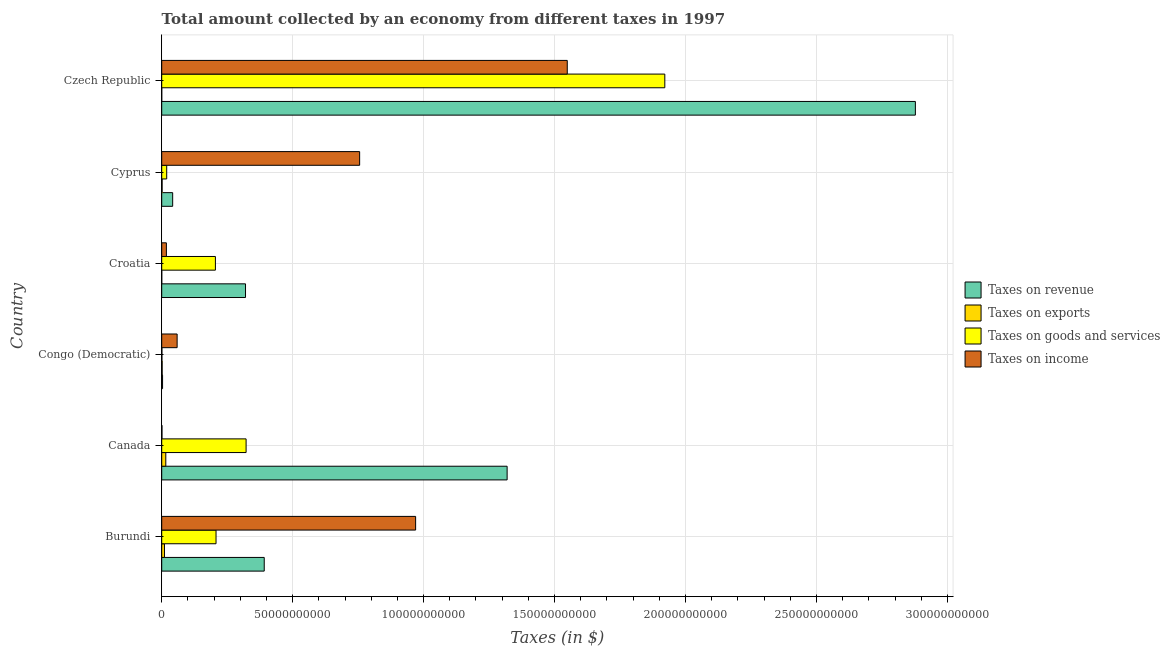How many groups of bars are there?
Offer a terse response. 6. What is the label of the 4th group of bars from the top?
Make the answer very short. Congo (Democratic). In how many cases, is the number of bars for a given country not equal to the number of legend labels?
Provide a short and direct response. 0. What is the amount collected as tax on goods in Cyprus?
Offer a terse response. 1.91e+09. Across all countries, what is the maximum amount collected as tax on income?
Make the answer very short. 1.55e+11. Across all countries, what is the minimum amount collected as tax on exports?
Ensure brevity in your answer.  4.00e+06. In which country was the amount collected as tax on exports maximum?
Ensure brevity in your answer.  Canada. In which country was the amount collected as tax on income minimum?
Offer a terse response. Canada. What is the total amount collected as tax on goods in the graph?
Ensure brevity in your answer.  2.68e+11. What is the difference between the amount collected as tax on goods in Canada and that in Cyprus?
Offer a very short reply. 3.03e+1. What is the difference between the amount collected as tax on goods in Croatia and the amount collected as tax on revenue in Canada?
Give a very brief answer. -1.11e+11. What is the average amount collected as tax on revenue per country?
Make the answer very short. 8.26e+1. What is the difference between the amount collected as tax on revenue and amount collected as tax on exports in Czech Republic?
Your response must be concise. 2.88e+11. What is the ratio of the amount collected as tax on income in Burundi to that in Congo (Democratic)?
Make the answer very short. 16.47. Is the amount collected as tax on goods in Canada less than that in Congo (Democratic)?
Offer a terse response. No. Is the difference between the amount collected as tax on income in Congo (Democratic) and Croatia greater than the difference between the amount collected as tax on revenue in Congo (Democratic) and Croatia?
Provide a succinct answer. Yes. What is the difference between the highest and the second highest amount collected as tax on income?
Give a very brief answer. 5.79e+1. What is the difference between the highest and the lowest amount collected as tax on revenue?
Provide a short and direct response. 2.87e+11. Is it the case that in every country, the sum of the amount collected as tax on revenue and amount collected as tax on goods is greater than the sum of amount collected as tax on exports and amount collected as tax on income?
Ensure brevity in your answer.  No. What does the 1st bar from the top in Canada represents?
Provide a succinct answer. Taxes on income. What does the 2nd bar from the bottom in Congo (Democratic) represents?
Your answer should be very brief. Taxes on exports. Is it the case that in every country, the sum of the amount collected as tax on revenue and amount collected as tax on exports is greater than the amount collected as tax on goods?
Provide a succinct answer. Yes. How many bars are there?
Provide a short and direct response. 24. Are all the bars in the graph horizontal?
Make the answer very short. Yes. How many countries are there in the graph?
Your response must be concise. 6. What is the difference between two consecutive major ticks on the X-axis?
Ensure brevity in your answer.  5.00e+1. Where does the legend appear in the graph?
Offer a very short reply. Center right. How many legend labels are there?
Keep it short and to the point. 4. What is the title of the graph?
Keep it short and to the point. Total amount collected by an economy from different taxes in 1997. Does "Natural Gas" appear as one of the legend labels in the graph?
Your answer should be very brief. No. What is the label or title of the X-axis?
Your answer should be very brief. Taxes (in $). What is the Taxes (in $) of Taxes on revenue in Burundi?
Offer a very short reply. 3.91e+1. What is the Taxes (in $) of Taxes on exports in Burundi?
Offer a terse response. 1.05e+09. What is the Taxes (in $) of Taxes on goods and services in Burundi?
Your answer should be very brief. 2.07e+1. What is the Taxes (in $) in Taxes on income in Burundi?
Provide a short and direct response. 9.70e+1. What is the Taxes (in $) of Taxes on revenue in Canada?
Ensure brevity in your answer.  1.32e+11. What is the Taxes (in $) of Taxes on exports in Canada?
Make the answer very short. 1.56e+09. What is the Taxes (in $) of Taxes on goods and services in Canada?
Offer a very short reply. 3.22e+1. What is the Taxes (in $) of Taxes on income in Canada?
Offer a very short reply. 1.01e+08. What is the Taxes (in $) of Taxes on revenue in Congo (Democratic)?
Provide a short and direct response. 3.24e+08. What is the Taxes (in $) of Taxes on exports in Congo (Democratic)?
Provide a succinct answer. 1.68e+08. What is the Taxes (in $) of Taxes on goods and services in Congo (Democratic)?
Keep it short and to the point. 7.41e+07. What is the Taxes (in $) in Taxes on income in Congo (Democratic)?
Ensure brevity in your answer.  5.89e+09. What is the Taxes (in $) of Taxes on revenue in Croatia?
Offer a very short reply. 3.20e+1. What is the Taxes (in $) of Taxes on exports in Croatia?
Provide a succinct answer. 6.20e+06. What is the Taxes (in $) in Taxes on goods and services in Croatia?
Provide a succinct answer. 2.05e+1. What is the Taxes (in $) in Taxes on income in Croatia?
Provide a short and direct response. 1.78e+09. What is the Taxes (in $) in Taxes on revenue in Cyprus?
Offer a very short reply. 4.18e+09. What is the Taxes (in $) of Taxes on exports in Cyprus?
Ensure brevity in your answer.  1.49e+08. What is the Taxes (in $) of Taxes on goods and services in Cyprus?
Ensure brevity in your answer.  1.91e+09. What is the Taxes (in $) of Taxes on income in Cyprus?
Offer a very short reply. 7.56e+1. What is the Taxes (in $) in Taxes on revenue in Czech Republic?
Your response must be concise. 2.88e+11. What is the Taxes (in $) of Taxes on goods and services in Czech Republic?
Your answer should be compact. 1.92e+11. What is the Taxes (in $) in Taxes on income in Czech Republic?
Offer a terse response. 1.55e+11. Across all countries, what is the maximum Taxes (in $) of Taxes on revenue?
Your answer should be compact. 2.88e+11. Across all countries, what is the maximum Taxes (in $) in Taxes on exports?
Your answer should be compact. 1.56e+09. Across all countries, what is the maximum Taxes (in $) of Taxes on goods and services?
Keep it short and to the point. 1.92e+11. Across all countries, what is the maximum Taxes (in $) of Taxes on income?
Ensure brevity in your answer.  1.55e+11. Across all countries, what is the minimum Taxes (in $) of Taxes on revenue?
Ensure brevity in your answer.  3.24e+08. Across all countries, what is the minimum Taxes (in $) of Taxes on exports?
Your answer should be compact. 4.00e+06. Across all countries, what is the minimum Taxes (in $) in Taxes on goods and services?
Give a very brief answer. 7.41e+07. Across all countries, what is the minimum Taxes (in $) of Taxes on income?
Provide a succinct answer. 1.01e+08. What is the total Taxes (in $) in Taxes on revenue in the graph?
Offer a terse response. 4.95e+11. What is the total Taxes (in $) in Taxes on exports in the graph?
Provide a succinct answer. 2.94e+09. What is the total Taxes (in $) of Taxes on goods and services in the graph?
Ensure brevity in your answer.  2.68e+11. What is the total Taxes (in $) of Taxes on income in the graph?
Provide a short and direct response. 3.35e+11. What is the difference between the Taxes (in $) of Taxes on revenue in Burundi and that in Canada?
Provide a short and direct response. -9.27e+1. What is the difference between the Taxes (in $) of Taxes on exports in Burundi and that in Canada?
Ensure brevity in your answer.  -5.06e+08. What is the difference between the Taxes (in $) of Taxes on goods and services in Burundi and that in Canada?
Your answer should be very brief. -1.15e+1. What is the difference between the Taxes (in $) in Taxes on income in Burundi and that in Canada?
Offer a terse response. 9.69e+1. What is the difference between the Taxes (in $) in Taxes on revenue in Burundi and that in Congo (Democratic)?
Your response must be concise. 3.88e+1. What is the difference between the Taxes (in $) of Taxes on exports in Burundi and that in Congo (Democratic)?
Your response must be concise. 8.85e+08. What is the difference between the Taxes (in $) in Taxes on goods and services in Burundi and that in Congo (Democratic)?
Provide a succinct answer. 2.07e+1. What is the difference between the Taxes (in $) in Taxes on income in Burundi and that in Congo (Democratic)?
Your response must be concise. 9.11e+1. What is the difference between the Taxes (in $) of Taxes on revenue in Burundi and that in Croatia?
Give a very brief answer. 7.15e+09. What is the difference between the Taxes (in $) of Taxes on exports in Burundi and that in Croatia?
Provide a succinct answer. 1.05e+09. What is the difference between the Taxes (in $) in Taxes on goods and services in Burundi and that in Croatia?
Your answer should be compact. 2.42e+08. What is the difference between the Taxes (in $) in Taxes on income in Burundi and that in Croatia?
Offer a terse response. 9.52e+1. What is the difference between the Taxes (in $) in Taxes on revenue in Burundi and that in Cyprus?
Offer a terse response. 3.50e+1. What is the difference between the Taxes (in $) of Taxes on exports in Burundi and that in Cyprus?
Your response must be concise. 9.04e+08. What is the difference between the Taxes (in $) of Taxes on goods and services in Burundi and that in Cyprus?
Provide a short and direct response. 1.88e+1. What is the difference between the Taxes (in $) of Taxes on income in Burundi and that in Cyprus?
Offer a terse response. 2.14e+1. What is the difference between the Taxes (in $) of Taxes on revenue in Burundi and that in Czech Republic?
Keep it short and to the point. -2.49e+11. What is the difference between the Taxes (in $) in Taxes on exports in Burundi and that in Czech Republic?
Offer a very short reply. 1.05e+09. What is the difference between the Taxes (in $) of Taxes on goods and services in Burundi and that in Czech Republic?
Your answer should be compact. -1.71e+11. What is the difference between the Taxes (in $) in Taxes on income in Burundi and that in Czech Republic?
Provide a succinct answer. -5.79e+1. What is the difference between the Taxes (in $) in Taxes on revenue in Canada and that in Congo (Democratic)?
Your answer should be very brief. 1.32e+11. What is the difference between the Taxes (in $) of Taxes on exports in Canada and that in Congo (Democratic)?
Make the answer very short. 1.39e+09. What is the difference between the Taxes (in $) of Taxes on goods and services in Canada and that in Congo (Democratic)?
Offer a very short reply. 3.21e+1. What is the difference between the Taxes (in $) in Taxes on income in Canada and that in Congo (Democratic)?
Your response must be concise. -5.79e+09. What is the difference between the Taxes (in $) in Taxes on revenue in Canada and that in Croatia?
Keep it short and to the point. 9.99e+1. What is the difference between the Taxes (in $) of Taxes on exports in Canada and that in Croatia?
Make the answer very short. 1.55e+09. What is the difference between the Taxes (in $) in Taxes on goods and services in Canada and that in Croatia?
Ensure brevity in your answer.  1.17e+1. What is the difference between the Taxes (in $) of Taxes on income in Canada and that in Croatia?
Make the answer very short. -1.68e+09. What is the difference between the Taxes (in $) in Taxes on revenue in Canada and that in Cyprus?
Your response must be concise. 1.28e+11. What is the difference between the Taxes (in $) in Taxes on exports in Canada and that in Cyprus?
Offer a very short reply. 1.41e+09. What is the difference between the Taxes (in $) in Taxes on goods and services in Canada and that in Cyprus?
Your answer should be compact. 3.03e+1. What is the difference between the Taxes (in $) in Taxes on income in Canada and that in Cyprus?
Give a very brief answer. -7.55e+1. What is the difference between the Taxes (in $) in Taxes on revenue in Canada and that in Czech Republic?
Provide a succinct answer. -1.56e+11. What is the difference between the Taxes (in $) in Taxes on exports in Canada and that in Czech Republic?
Ensure brevity in your answer.  1.56e+09. What is the difference between the Taxes (in $) in Taxes on goods and services in Canada and that in Czech Republic?
Your answer should be very brief. -1.60e+11. What is the difference between the Taxes (in $) of Taxes on income in Canada and that in Czech Republic?
Offer a very short reply. -1.55e+11. What is the difference between the Taxes (in $) in Taxes on revenue in Congo (Democratic) and that in Croatia?
Your response must be concise. -3.17e+1. What is the difference between the Taxes (in $) in Taxes on exports in Congo (Democratic) and that in Croatia?
Your response must be concise. 1.62e+08. What is the difference between the Taxes (in $) of Taxes on goods and services in Congo (Democratic) and that in Croatia?
Offer a very short reply. -2.04e+1. What is the difference between the Taxes (in $) of Taxes on income in Congo (Democratic) and that in Croatia?
Provide a succinct answer. 4.10e+09. What is the difference between the Taxes (in $) in Taxes on revenue in Congo (Democratic) and that in Cyprus?
Ensure brevity in your answer.  -3.86e+09. What is the difference between the Taxes (in $) in Taxes on exports in Congo (Democratic) and that in Cyprus?
Provide a short and direct response. 1.86e+07. What is the difference between the Taxes (in $) in Taxes on goods and services in Congo (Democratic) and that in Cyprus?
Your answer should be compact. -1.83e+09. What is the difference between the Taxes (in $) in Taxes on income in Congo (Democratic) and that in Cyprus?
Offer a very short reply. -6.97e+1. What is the difference between the Taxes (in $) of Taxes on revenue in Congo (Democratic) and that in Czech Republic?
Provide a short and direct response. -2.87e+11. What is the difference between the Taxes (in $) in Taxes on exports in Congo (Democratic) and that in Czech Republic?
Offer a very short reply. 1.64e+08. What is the difference between the Taxes (in $) of Taxes on goods and services in Congo (Democratic) and that in Czech Republic?
Your response must be concise. -1.92e+11. What is the difference between the Taxes (in $) in Taxes on income in Congo (Democratic) and that in Czech Republic?
Ensure brevity in your answer.  -1.49e+11. What is the difference between the Taxes (in $) of Taxes on revenue in Croatia and that in Cyprus?
Ensure brevity in your answer.  2.78e+1. What is the difference between the Taxes (in $) of Taxes on exports in Croatia and that in Cyprus?
Ensure brevity in your answer.  -1.43e+08. What is the difference between the Taxes (in $) in Taxes on goods and services in Croatia and that in Cyprus?
Keep it short and to the point. 1.86e+1. What is the difference between the Taxes (in $) of Taxes on income in Croatia and that in Cyprus?
Provide a succinct answer. -7.38e+1. What is the difference between the Taxes (in $) in Taxes on revenue in Croatia and that in Czech Republic?
Ensure brevity in your answer.  -2.56e+11. What is the difference between the Taxes (in $) of Taxes on exports in Croatia and that in Czech Republic?
Provide a short and direct response. 2.20e+06. What is the difference between the Taxes (in $) in Taxes on goods and services in Croatia and that in Czech Republic?
Give a very brief answer. -1.72e+11. What is the difference between the Taxes (in $) of Taxes on income in Croatia and that in Czech Republic?
Your answer should be very brief. -1.53e+11. What is the difference between the Taxes (in $) of Taxes on revenue in Cyprus and that in Czech Republic?
Make the answer very short. -2.84e+11. What is the difference between the Taxes (in $) in Taxes on exports in Cyprus and that in Czech Republic?
Offer a terse response. 1.45e+08. What is the difference between the Taxes (in $) of Taxes on goods and services in Cyprus and that in Czech Republic?
Give a very brief answer. -1.90e+11. What is the difference between the Taxes (in $) of Taxes on income in Cyprus and that in Czech Republic?
Keep it short and to the point. -7.93e+1. What is the difference between the Taxes (in $) in Taxes on revenue in Burundi and the Taxes (in $) in Taxes on exports in Canada?
Provide a succinct answer. 3.76e+1. What is the difference between the Taxes (in $) of Taxes on revenue in Burundi and the Taxes (in $) of Taxes on goods and services in Canada?
Your answer should be very brief. 6.93e+09. What is the difference between the Taxes (in $) of Taxes on revenue in Burundi and the Taxes (in $) of Taxes on income in Canada?
Your answer should be compact. 3.90e+1. What is the difference between the Taxes (in $) of Taxes on exports in Burundi and the Taxes (in $) of Taxes on goods and services in Canada?
Give a very brief answer. -3.12e+1. What is the difference between the Taxes (in $) in Taxes on exports in Burundi and the Taxes (in $) in Taxes on income in Canada?
Your response must be concise. 9.52e+08. What is the difference between the Taxes (in $) in Taxes on goods and services in Burundi and the Taxes (in $) in Taxes on income in Canada?
Your answer should be compact. 2.06e+1. What is the difference between the Taxes (in $) of Taxes on revenue in Burundi and the Taxes (in $) of Taxes on exports in Congo (Democratic)?
Keep it short and to the point. 3.90e+1. What is the difference between the Taxes (in $) in Taxes on revenue in Burundi and the Taxes (in $) in Taxes on goods and services in Congo (Democratic)?
Offer a very short reply. 3.91e+1. What is the difference between the Taxes (in $) of Taxes on revenue in Burundi and the Taxes (in $) of Taxes on income in Congo (Democratic)?
Provide a short and direct response. 3.33e+1. What is the difference between the Taxes (in $) in Taxes on exports in Burundi and the Taxes (in $) in Taxes on goods and services in Congo (Democratic)?
Provide a succinct answer. 9.79e+08. What is the difference between the Taxes (in $) in Taxes on exports in Burundi and the Taxes (in $) in Taxes on income in Congo (Democratic)?
Make the answer very short. -4.83e+09. What is the difference between the Taxes (in $) of Taxes on goods and services in Burundi and the Taxes (in $) of Taxes on income in Congo (Democratic)?
Your answer should be very brief. 1.49e+1. What is the difference between the Taxes (in $) in Taxes on revenue in Burundi and the Taxes (in $) in Taxes on exports in Croatia?
Make the answer very short. 3.91e+1. What is the difference between the Taxes (in $) in Taxes on revenue in Burundi and the Taxes (in $) in Taxes on goods and services in Croatia?
Make the answer very short. 1.86e+1. What is the difference between the Taxes (in $) in Taxes on revenue in Burundi and the Taxes (in $) in Taxes on income in Croatia?
Your answer should be very brief. 3.74e+1. What is the difference between the Taxes (in $) in Taxes on exports in Burundi and the Taxes (in $) in Taxes on goods and services in Croatia?
Offer a very short reply. -1.94e+1. What is the difference between the Taxes (in $) in Taxes on exports in Burundi and the Taxes (in $) in Taxes on income in Croatia?
Offer a very short reply. -7.31e+08. What is the difference between the Taxes (in $) in Taxes on goods and services in Burundi and the Taxes (in $) in Taxes on income in Croatia?
Provide a short and direct response. 1.90e+1. What is the difference between the Taxes (in $) of Taxes on revenue in Burundi and the Taxes (in $) of Taxes on exports in Cyprus?
Provide a succinct answer. 3.90e+1. What is the difference between the Taxes (in $) in Taxes on revenue in Burundi and the Taxes (in $) in Taxes on goods and services in Cyprus?
Keep it short and to the point. 3.72e+1. What is the difference between the Taxes (in $) of Taxes on revenue in Burundi and the Taxes (in $) of Taxes on income in Cyprus?
Offer a terse response. -3.64e+1. What is the difference between the Taxes (in $) in Taxes on exports in Burundi and the Taxes (in $) in Taxes on goods and services in Cyprus?
Your response must be concise. -8.52e+08. What is the difference between the Taxes (in $) of Taxes on exports in Burundi and the Taxes (in $) of Taxes on income in Cyprus?
Your answer should be very brief. -7.45e+1. What is the difference between the Taxes (in $) of Taxes on goods and services in Burundi and the Taxes (in $) of Taxes on income in Cyprus?
Your response must be concise. -5.48e+1. What is the difference between the Taxes (in $) of Taxes on revenue in Burundi and the Taxes (in $) of Taxes on exports in Czech Republic?
Provide a succinct answer. 3.91e+1. What is the difference between the Taxes (in $) in Taxes on revenue in Burundi and the Taxes (in $) in Taxes on goods and services in Czech Republic?
Ensure brevity in your answer.  -1.53e+11. What is the difference between the Taxes (in $) of Taxes on revenue in Burundi and the Taxes (in $) of Taxes on income in Czech Republic?
Your response must be concise. -1.16e+11. What is the difference between the Taxes (in $) of Taxes on exports in Burundi and the Taxes (in $) of Taxes on goods and services in Czech Republic?
Offer a terse response. -1.91e+11. What is the difference between the Taxes (in $) of Taxes on exports in Burundi and the Taxes (in $) of Taxes on income in Czech Republic?
Offer a very short reply. -1.54e+11. What is the difference between the Taxes (in $) in Taxes on goods and services in Burundi and the Taxes (in $) in Taxes on income in Czech Republic?
Keep it short and to the point. -1.34e+11. What is the difference between the Taxes (in $) of Taxes on revenue in Canada and the Taxes (in $) of Taxes on exports in Congo (Democratic)?
Your response must be concise. 1.32e+11. What is the difference between the Taxes (in $) in Taxes on revenue in Canada and the Taxes (in $) in Taxes on goods and services in Congo (Democratic)?
Make the answer very short. 1.32e+11. What is the difference between the Taxes (in $) of Taxes on revenue in Canada and the Taxes (in $) of Taxes on income in Congo (Democratic)?
Your answer should be very brief. 1.26e+11. What is the difference between the Taxes (in $) in Taxes on exports in Canada and the Taxes (in $) in Taxes on goods and services in Congo (Democratic)?
Your response must be concise. 1.48e+09. What is the difference between the Taxes (in $) of Taxes on exports in Canada and the Taxes (in $) of Taxes on income in Congo (Democratic)?
Your response must be concise. -4.33e+09. What is the difference between the Taxes (in $) in Taxes on goods and services in Canada and the Taxes (in $) in Taxes on income in Congo (Democratic)?
Provide a succinct answer. 2.63e+1. What is the difference between the Taxes (in $) of Taxes on revenue in Canada and the Taxes (in $) of Taxes on exports in Croatia?
Keep it short and to the point. 1.32e+11. What is the difference between the Taxes (in $) of Taxes on revenue in Canada and the Taxes (in $) of Taxes on goods and services in Croatia?
Your answer should be very brief. 1.11e+11. What is the difference between the Taxes (in $) in Taxes on revenue in Canada and the Taxes (in $) in Taxes on income in Croatia?
Give a very brief answer. 1.30e+11. What is the difference between the Taxes (in $) in Taxes on exports in Canada and the Taxes (in $) in Taxes on goods and services in Croatia?
Ensure brevity in your answer.  -1.89e+1. What is the difference between the Taxes (in $) in Taxes on exports in Canada and the Taxes (in $) in Taxes on income in Croatia?
Your response must be concise. -2.25e+08. What is the difference between the Taxes (in $) of Taxes on goods and services in Canada and the Taxes (in $) of Taxes on income in Croatia?
Keep it short and to the point. 3.04e+1. What is the difference between the Taxes (in $) of Taxes on revenue in Canada and the Taxes (in $) of Taxes on exports in Cyprus?
Your answer should be compact. 1.32e+11. What is the difference between the Taxes (in $) of Taxes on revenue in Canada and the Taxes (in $) of Taxes on goods and services in Cyprus?
Offer a terse response. 1.30e+11. What is the difference between the Taxes (in $) in Taxes on revenue in Canada and the Taxes (in $) in Taxes on income in Cyprus?
Keep it short and to the point. 5.63e+1. What is the difference between the Taxes (in $) in Taxes on exports in Canada and the Taxes (in $) in Taxes on goods and services in Cyprus?
Provide a succinct answer. -3.46e+08. What is the difference between the Taxes (in $) of Taxes on exports in Canada and the Taxes (in $) of Taxes on income in Cyprus?
Provide a short and direct response. -7.40e+1. What is the difference between the Taxes (in $) in Taxes on goods and services in Canada and the Taxes (in $) in Taxes on income in Cyprus?
Your answer should be very brief. -4.34e+1. What is the difference between the Taxes (in $) of Taxes on revenue in Canada and the Taxes (in $) of Taxes on exports in Czech Republic?
Your answer should be compact. 1.32e+11. What is the difference between the Taxes (in $) in Taxes on revenue in Canada and the Taxes (in $) in Taxes on goods and services in Czech Republic?
Give a very brief answer. -6.02e+1. What is the difference between the Taxes (in $) of Taxes on revenue in Canada and the Taxes (in $) of Taxes on income in Czech Republic?
Provide a succinct answer. -2.30e+1. What is the difference between the Taxes (in $) of Taxes on exports in Canada and the Taxes (in $) of Taxes on goods and services in Czech Republic?
Offer a very short reply. -1.91e+11. What is the difference between the Taxes (in $) of Taxes on exports in Canada and the Taxes (in $) of Taxes on income in Czech Republic?
Provide a succinct answer. -1.53e+11. What is the difference between the Taxes (in $) of Taxes on goods and services in Canada and the Taxes (in $) of Taxes on income in Czech Republic?
Ensure brevity in your answer.  -1.23e+11. What is the difference between the Taxes (in $) in Taxes on revenue in Congo (Democratic) and the Taxes (in $) in Taxes on exports in Croatia?
Provide a short and direct response. 3.18e+08. What is the difference between the Taxes (in $) in Taxes on revenue in Congo (Democratic) and the Taxes (in $) in Taxes on goods and services in Croatia?
Your response must be concise. -2.02e+1. What is the difference between the Taxes (in $) of Taxes on revenue in Congo (Democratic) and the Taxes (in $) of Taxes on income in Croatia?
Provide a succinct answer. -1.46e+09. What is the difference between the Taxes (in $) of Taxes on exports in Congo (Democratic) and the Taxes (in $) of Taxes on goods and services in Croatia?
Keep it short and to the point. -2.03e+1. What is the difference between the Taxes (in $) in Taxes on exports in Congo (Democratic) and the Taxes (in $) in Taxes on income in Croatia?
Your answer should be very brief. -1.62e+09. What is the difference between the Taxes (in $) in Taxes on goods and services in Congo (Democratic) and the Taxes (in $) in Taxes on income in Croatia?
Provide a succinct answer. -1.71e+09. What is the difference between the Taxes (in $) in Taxes on revenue in Congo (Democratic) and the Taxes (in $) in Taxes on exports in Cyprus?
Offer a terse response. 1.75e+08. What is the difference between the Taxes (in $) of Taxes on revenue in Congo (Democratic) and the Taxes (in $) of Taxes on goods and services in Cyprus?
Keep it short and to the point. -1.58e+09. What is the difference between the Taxes (in $) in Taxes on revenue in Congo (Democratic) and the Taxes (in $) in Taxes on income in Cyprus?
Give a very brief answer. -7.53e+1. What is the difference between the Taxes (in $) in Taxes on exports in Congo (Democratic) and the Taxes (in $) in Taxes on goods and services in Cyprus?
Your response must be concise. -1.74e+09. What is the difference between the Taxes (in $) in Taxes on exports in Congo (Democratic) and the Taxes (in $) in Taxes on income in Cyprus?
Your answer should be compact. -7.54e+1. What is the difference between the Taxes (in $) of Taxes on goods and services in Congo (Democratic) and the Taxes (in $) of Taxes on income in Cyprus?
Provide a short and direct response. -7.55e+1. What is the difference between the Taxes (in $) of Taxes on revenue in Congo (Democratic) and the Taxes (in $) of Taxes on exports in Czech Republic?
Give a very brief answer. 3.20e+08. What is the difference between the Taxes (in $) in Taxes on revenue in Congo (Democratic) and the Taxes (in $) in Taxes on goods and services in Czech Republic?
Your response must be concise. -1.92e+11. What is the difference between the Taxes (in $) in Taxes on revenue in Congo (Democratic) and the Taxes (in $) in Taxes on income in Czech Republic?
Keep it short and to the point. -1.55e+11. What is the difference between the Taxes (in $) in Taxes on exports in Congo (Democratic) and the Taxes (in $) in Taxes on goods and services in Czech Republic?
Give a very brief answer. -1.92e+11. What is the difference between the Taxes (in $) in Taxes on exports in Congo (Democratic) and the Taxes (in $) in Taxes on income in Czech Republic?
Your answer should be very brief. -1.55e+11. What is the difference between the Taxes (in $) in Taxes on goods and services in Congo (Democratic) and the Taxes (in $) in Taxes on income in Czech Republic?
Give a very brief answer. -1.55e+11. What is the difference between the Taxes (in $) of Taxes on revenue in Croatia and the Taxes (in $) of Taxes on exports in Cyprus?
Offer a very short reply. 3.19e+1. What is the difference between the Taxes (in $) in Taxes on revenue in Croatia and the Taxes (in $) in Taxes on goods and services in Cyprus?
Offer a very short reply. 3.01e+1. What is the difference between the Taxes (in $) of Taxes on revenue in Croatia and the Taxes (in $) of Taxes on income in Cyprus?
Your answer should be compact. -4.36e+1. What is the difference between the Taxes (in $) in Taxes on exports in Croatia and the Taxes (in $) in Taxes on goods and services in Cyprus?
Your answer should be compact. -1.90e+09. What is the difference between the Taxes (in $) of Taxes on exports in Croatia and the Taxes (in $) of Taxes on income in Cyprus?
Your answer should be compact. -7.56e+1. What is the difference between the Taxes (in $) in Taxes on goods and services in Croatia and the Taxes (in $) in Taxes on income in Cyprus?
Provide a succinct answer. -5.51e+1. What is the difference between the Taxes (in $) in Taxes on revenue in Croatia and the Taxes (in $) in Taxes on exports in Czech Republic?
Provide a short and direct response. 3.20e+1. What is the difference between the Taxes (in $) of Taxes on revenue in Croatia and the Taxes (in $) of Taxes on goods and services in Czech Republic?
Keep it short and to the point. -1.60e+11. What is the difference between the Taxes (in $) in Taxes on revenue in Croatia and the Taxes (in $) in Taxes on income in Czech Republic?
Offer a very short reply. -1.23e+11. What is the difference between the Taxes (in $) of Taxes on exports in Croatia and the Taxes (in $) of Taxes on goods and services in Czech Republic?
Offer a very short reply. -1.92e+11. What is the difference between the Taxes (in $) in Taxes on exports in Croatia and the Taxes (in $) in Taxes on income in Czech Republic?
Ensure brevity in your answer.  -1.55e+11. What is the difference between the Taxes (in $) of Taxes on goods and services in Croatia and the Taxes (in $) of Taxes on income in Czech Republic?
Your response must be concise. -1.34e+11. What is the difference between the Taxes (in $) of Taxes on revenue in Cyprus and the Taxes (in $) of Taxes on exports in Czech Republic?
Your response must be concise. 4.18e+09. What is the difference between the Taxes (in $) in Taxes on revenue in Cyprus and the Taxes (in $) in Taxes on goods and services in Czech Republic?
Provide a succinct answer. -1.88e+11. What is the difference between the Taxes (in $) in Taxes on revenue in Cyprus and the Taxes (in $) in Taxes on income in Czech Republic?
Provide a succinct answer. -1.51e+11. What is the difference between the Taxes (in $) in Taxes on exports in Cyprus and the Taxes (in $) in Taxes on goods and services in Czech Republic?
Ensure brevity in your answer.  -1.92e+11. What is the difference between the Taxes (in $) of Taxes on exports in Cyprus and the Taxes (in $) of Taxes on income in Czech Republic?
Keep it short and to the point. -1.55e+11. What is the difference between the Taxes (in $) of Taxes on goods and services in Cyprus and the Taxes (in $) of Taxes on income in Czech Republic?
Make the answer very short. -1.53e+11. What is the average Taxes (in $) of Taxes on revenue per country?
Offer a very short reply. 8.26e+1. What is the average Taxes (in $) of Taxes on exports per country?
Your answer should be compact. 4.90e+08. What is the average Taxes (in $) of Taxes on goods and services per country?
Keep it short and to the point. 4.46e+1. What is the average Taxes (in $) of Taxes on income per country?
Keep it short and to the point. 5.59e+1. What is the difference between the Taxes (in $) in Taxes on revenue and Taxes (in $) in Taxes on exports in Burundi?
Ensure brevity in your answer.  3.81e+1. What is the difference between the Taxes (in $) in Taxes on revenue and Taxes (in $) in Taxes on goods and services in Burundi?
Make the answer very short. 1.84e+1. What is the difference between the Taxes (in $) of Taxes on revenue and Taxes (in $) of Taxes on income in Burundi?
Provide a short and direct response. -5.78e+1. What is the difference between the Taxes (in $) in Taxes on exports and Taxes (in $) in Taxes on goods and services in Burundi?
Your answer should be compact. -1.97e+1. What is the difference between the Taxes (in $) in Taxes on exports and Taxes (in $) in Taxes on income in Burundi?
Your answer should be very brief. -9.59e+1. What is the difference between the Taxes (in $) in Taxes on goods and services and Taxes (in $) in Taxes on income in Burundi?
Your response must be concise. -7.62e+1. What is the difference between the Taxes (in $) of Taxes on revenue and Taxes (in $) of Taxes on exports in Canada?
Provide a succinct answer. 1.30e+11. What is the difference between the Taxes (in $) in Taxes on revenue and Taxes (in $) in Taxes on goods and services in Canada?
Your response must be concise. 9.97e+1. What is the difference between the Taxes (in $) of Taxes on revenue and Taxes (in $) of Taxes on income in Canada?
Provide a succinct answer. 1.32e+11. What is the difference between the Taxes (in $) of Taxes on exports and Taxes (in $) of Taxes on goods and services in Canada?
Your response must be concise. -3.07e+1. What is the difference between the Taxes (in $) of Taxes on exports and Taxes (in $) of Taxes on income in Canada?
Give a very brief answer. 1.46e+09. What is the difference between the Taxes (in $) of Taxes on goods and services and Taxes (in $) of Taxes on income in Canada?
Your answer should be very brief. 3.21e+1. What is the difference between the Taxes (in $) in Taxes on revenue and Taxes (in $) in Taxes on exports in Congo (Democratic)?
Offer a terse response. 1.56e+08. What is the difference between the Taxes (in $) of Taxes on revenue and Taxes (in $) of Taxes on goods and services in Congo (Democratic)?
Offer a terse response. 2.50e+08. What is the difference between the Taxes (in $) of Taxes on revenue and Taxes (in $) of Taxes on income in Congo (Democratic)?
Keep it short and to the point. -5.56e+09. What is the difference between the Taxes (in $) in Taxes on exports and Taxes (in $) in Taxes on goods and services in Congo (Democratic)?
Make the answer very short. 9.39e+07. What is the difference between the Taxes (in $) of Taxes on exports and Taxes (in $) of Taxes on income in Congo (Democratic)?
Provide a succinct answer. -5.72e+09. What is the difference between the Taxes (in $) of Taxes on goods and services and Taxes (in $) of Taxes on income in Congo (Democratic)?
Keep it short and to the point. -5.81e+09. What is the difference between the Taxes (in $) in Taxes on revenue and Taxes (in $) in Taxes on exports in Croatia?
Your answer should be very brief. 3.20e+1. What is the difference between the Taxes (in $) in Taxes on revenue and Taxes (in $) in Taxes on goods and services in Croatia?
Offer a very short reply. 1.15e+1. What is the difference between the Taxes (in $) of Taxes on revenue and Taxes (in $) of Taxes on income in Croatia?
Keep it short and to the point. 3.02e+1. What is the difference between the Taxes (in $) of Taxes on exports and Taxes (in $) of Taxes on goods and services in Croatia?
Give a very brief answer. -2.05e+1. What is the difference between the Taxes (in $) in Taxes on exports and Taxes (in $) in Taxes on income in Croatia?
Ensure brevity in your answer.  -1.78e+09. What is the difference between the Taxes (in $) in Taxes on goods and services and Taxes (in $) in Taxes on income in Croatia?
Ensure brevity in your answer.  1.87e+1. What is the difference between the Taxes (in $) in Taxes on revenue and Taxes (in $) in Taxes on exports in Cyprus?
Provide a succinct answer. 4.04e+09. What is the difference between the Taxes (in $) in Taxes on revenue and Taxes (in $) in Taxes on goods and services in Cyprus?
Your answer should be very brief. 2.28e+09. What is the difference between the Taxes (in $) of Taxes on revenue and Taxes (in $) of Taxes on income in Cyprus?
Your response must be concise. -7.14e+1. What is the difference between the Taxes (in $) in Taxes on exports and Taxes (in $) in Taxes on goods and services in Cyprus?
Ensure brevity in your answer.  -1.76e+09. What is the difference between the Taxes (in $) in Taxes on exports and Taxes (in $) in Taxes on income in Cyprus?
Keep it short and to the point. -7.54e+1. What is the difference between the Taxes (in $) of Taxes on goods and services and Taxes (in $) of Taxes on income in Cyprus?
Provide a succinct answer. -7.37e+1. What is the difference between the Taxes (in $) of Taxes on revenue and Taxes (in $) of Taxes on exports in Czech Republic?
Offer a very short reply. 2.88e+11. What is the difference between the Taxes (in $) of Taxes on revenue and Taxes (in $) of Taxes on goods and services in Czech Republic?
Your answer should be compact. 9.57e+1. What is the difference between the Taxes (in $) of Taxes on revenue and Taxes (in $) of Taxes on income in Czech Republic?
Your answer should be compact. 1.33e+11. What is the difference between the Taxes (in $) of Taxes on exports and Taxes (in $) of Taxes on goods and services in Czech Republic?
Your response must be concise. -1.92e+11. What is the difference between the Taxes (in $) in Taxes on exports and Taxes (in $) in Taxes on income in Czech Republic?
Provide a short and direct response. -1.55e+11. What is the difference between the Taxes (in $) of Taxes on goods and services and Taxes (in $) of Taxes on income in Czech Republic?
Provide a succinct answer. 3.72e+1. What is the ratio of the Taxes (in $) in Taxes on revenue in Burundi to that in Canada?
Your response must be concise. 0.3. What is the ratio of the Taxes (in $) of Taxes on exports in Burundi to that in Canada?
Offer a very short reply. 0.68. What is the ratio of the Taxes (in $) of Taxes on goods and services in Burundi to that in Canada?
Ensure brevity in your answer.  0.64. What is the ratio of the Taxes (in $) of Taxes on income in Burundi to that in Canada?
Your answer should be compact. 963.02. What is the ratio of the Taxes (in $) of Taxes on revenue in Burundi to that in Congo (Democratic)?
Provide a short and direct response. 120.72. What is the ratio of the Taxes (in $) of Taxes on exports in Burundi to that in Congo (Democratic)?
Keep it short and to the point. 6.27. What is the ratio of the Taxes (in $) of Taxes on goods and services in Burundi to that in Congo (Democratic)?
Provide a short and direct response. 280.1. What is the ratio of the Taxes (in $) of Taxes on income in Burundi to that in Congo (Democratic)?
Ensure brevity in your answer.  16.47. What is the ratio of the Taxes (in $) in Taxes on revenue in Burundi to that in Croatia?
Offer a terse response. 1.22. What is the ratio of the Taxes (in $) in Taxes on exports in Burundi to that in Croatia?
Your answer should be compact. 169.84. What is the ratio of the Taxes (in $) of Taxes on goods and services in Burundi to that in Croatia?
Ensure brevity in your answer.  1.01. What is the ratio of the Taxes (in $) of Taxes on income in Burundi to that in Croatia?
Give a very brief answer. 54.35. What is the ratio of the Taxes (in $) of Taxes on revenue in Burundi to that in Cyprus?
Your response must be concise. 9.36. What is the ratio of the Taxes (in $) in Taxes on exports in Burundi to that in Cyprus?
Your answer should be very brief. 7.05. What is the ratio of the Taxes (in $) in Taxes on goods and services in Burundi to that in Cyprus?
Your answer should be very brief. 10.89. What is the ratio of the Taxes (in $) of Taxes on income in Burundi to that in Cyprus?
Keep it short and to the point. 1.28. What is the ratio of the Taxes (in $) in Taxes on revenue in Burundi to that in Czech Republic?
Provide a short and direct response. 0.14. What is the ratio of the Taxes (in $) in Taxes on exports in Burundi to that in Czech Republic?
Offer a terse response. 263.25. What is the ratio of the Taxes (in $) of Taxes on goods and services in Burundi to that in Czech Republic?
Make the answer very short. 0.11. What is the ratio of the Taxes (in $) in Taxes on income in Burundi to that in Czech Republic?
Your answer should be very brief. 0.63. What is the ratio of the Taxes (in $) of Taxes on revenue in Canada to that in Congo (Democratic)?
Your answer should be compact. 406.7. What is the ratio of the Taxes (in $) of Taxes on exports in Canada to that in Congo (Democratic)?
Provide a succinct answer. 9.28. What is the ratio of the Taxes (in $) in Taxes on goods and services in Canada to that in Congo (Democratic)?
Your response must be concise. 435.07. What is the ratio of the Taxes (in $) of Taxes on income in Canada to that in Congo (Democratic)?
Your answer should be compact. 0.02. What is the ratio of the Taxes (in $) in Taxes on revenue in Canada to that in Croatia?
Keep it short and to the point. 4.12. What is the ratio of the Taxes (in $) in Taxes on exports in Canada to that in Croatia?
Give a very brief answer. 251.45. What is the ratio of the Taxes (in $) of Taxes on goods and services in Canada to that in Croatia?
Make the answer very short. 1.57. What is the ratio of the Taxes (in $) of Taxes on income in Canada to that in Croatia?
Your answer should be very brief. 0.06. What is the ratio of the Taxes (in $) of Taxes on revenue in Canada to that in Cyprus?
Your answer should be compact. 31.52. What is the ratio of the Taxes (in $) of Taxes on exports in Canada to that in Cyprus?
Make the answer very short. 10.43. What is the ratio of the Taxes (in $) of Taxes on goods and services in Canada to that in Cyprus?
Your answer should be very brief. 16.91. What is the ratio of the Taxes (in $) of Taxes on income in Canada to that in Cyprus?
Keep it short and to the point. 0. What is the ratio of the Taxes (in $) in Taxes on revenue in Canada to that in Czech Republic?
Give a very brief answer. 0.46. What is the ratio of the Taxes (in $) of Taxes on exports in Canada to that in Czech Republic?
Provide a short and direct response. 389.75. What is the ratio of the Taxes (in $) of Taxes on goods and services in Canada to that in Czech Republic?
Your answer should be compact. 0.17. What is the ratio of the Taxes (in $) of Taxes on income in Canada to that in Czech Republic?
Make the answer very short. 0. What is the ratio of the Taxes (in $) of Taxes on revenue in Congo (Democratic) to that in Croatia?
Provide a short and direct response. 0.01. What is the ratio of the Taxes (in $) of Taxes on exports in Congo (Democratic) to that in Croatia?
Your answer should be compact. 27.1. What is the ratio of the Taxes (in $) of Taxes on goods and services in Congo (Democratic) to that in Croatia?
Your response must be concise. 0. What is the ratio of the Taxes (in $) of Taxes on income in Congo (Democratic) to that in Croatia?
Keep it short and to the point. 3.3. What is the ratio of the Taxes (in $) in Taxes on revenue in Congo (Democratic) to that in Cyprus?
Give a very brief answer. 0.08. What is the ratio of the Taxes (in $) of Taxes on exports in Congo (Democratic) to that in Cyprus?
Make the answer very short. 1.12. What is the ratio of the Taxes (in $) of Taxes on goods and services in Congo (Democratic) to that in Cyprus?
Ensure brevity in your answer.  0.04. What is the ratio of the Taxes (in $) in Taxes on income in Congo (Democratic) to that in Cyprus?
Give a very brief answer. 0.08. What is the ratio of the Taxes (in $) of Taxes on revenue in Congo (Democratic) to that in Czech Republic?
Provide a short and direct response. 0. What is the ratio of the Taxes (in $) of Taxes on goods and services in Congo (Democratic) to that in Czech Republic?
Your answer should be very brief. 0. What is the ratio of the Taxes (in $) in Taxes on income in Congo (Democratic) to that in Czech Republic?
Your response must be concise. 0.04. What is the ratio of the Taxes (in $) in Taxes on revenue in Croatia to that in Cyprus?
Your response must be concise. 7.65. What is the ratio of the Taxes (in $) in Taxes on exports in Croatia to that in Cyprus?
Your response must be concise. 0.04. What is the ratio of the Taxes (in $) in Taxes on goods and services in Croatia to that in Cyprus?
Provide a succinct answer. 10.76. What is the ratio of the Taxes (in $) of Taxes on income in Croatia to that in Cyprus?
Your response must be concise. 0.02. What is the ratio of the Taxes (in $) of Taxes on revenue in Croatia to that in Czech Republic?
Provide a succinct answer. 0.11. What is the ratio of the Taxes (in $) of Taxes on exports in Croatia to that in Czech Republic?
Make the answer very short. 1.55. What is the ratio of the Taxes (in $) of Taxes on goods and services in Croatia to that in Czech Republic?
Give a very brief answer. 0.11. What is the ratio of the Taxes (in $) of Taxes on income in Croatia to that in Czech Republic?
Offer a very short reply. 0.01. What is the ratio of the Taxes (in $) of Taxes on revenue in Cyprus to that in Czech Republic?
Give a very brief answer. 0.01. What is the ratio of the Taxes (in $) of Taxes on exports in Cyprus to that in Czech Republic?
Provide a succinct answer. 37.36. What is the ratio of the Taxes (in $) of Taxes on goods and services in Cyprus to that in Czech Republic?
Give a very brief answer. 0.01. What is the ratio of the Taxes (in $) of Taxes on income in Cyprus to that in Czech Republic?
Make the answer very short. 0.49. What is the difference between the highest and the second highest Taxes (in $) in Taxes on revenue?
Provide a short and direct response. 1.56e+11. What is the difference between the highest and the second highest Taxes (in $) of Taxes on exports?
Your answer should be compact. 5.06e+08. What is the difference between the highest and the second highest Taxes (in $) of Taxes on goods and services?
Your answer should be compact. 1.60e+11. What is the difference between the highest and the second highest Taxes (in $) of Taxes on income?
Provide a short and direct response. 5.79e+1. What is the difference between the highest and the lowest Taxes (in $) of Taxes on revenue?
Make the answer very short. 2.87e+11. What is the difference between the highest and the lowest Taxes (in $) of Taxes on exports?
Give a very brief answer. 1.56e+09. What is the difference between the highest and the lowest Taxes (in $) in Taxes on goods and services?
Your response must be concise. 1.92e+11. What is the difference between the highest and the lowest Taxes (in $) of Taxes on income?
Your answer should be compact. 1.55e+11. 